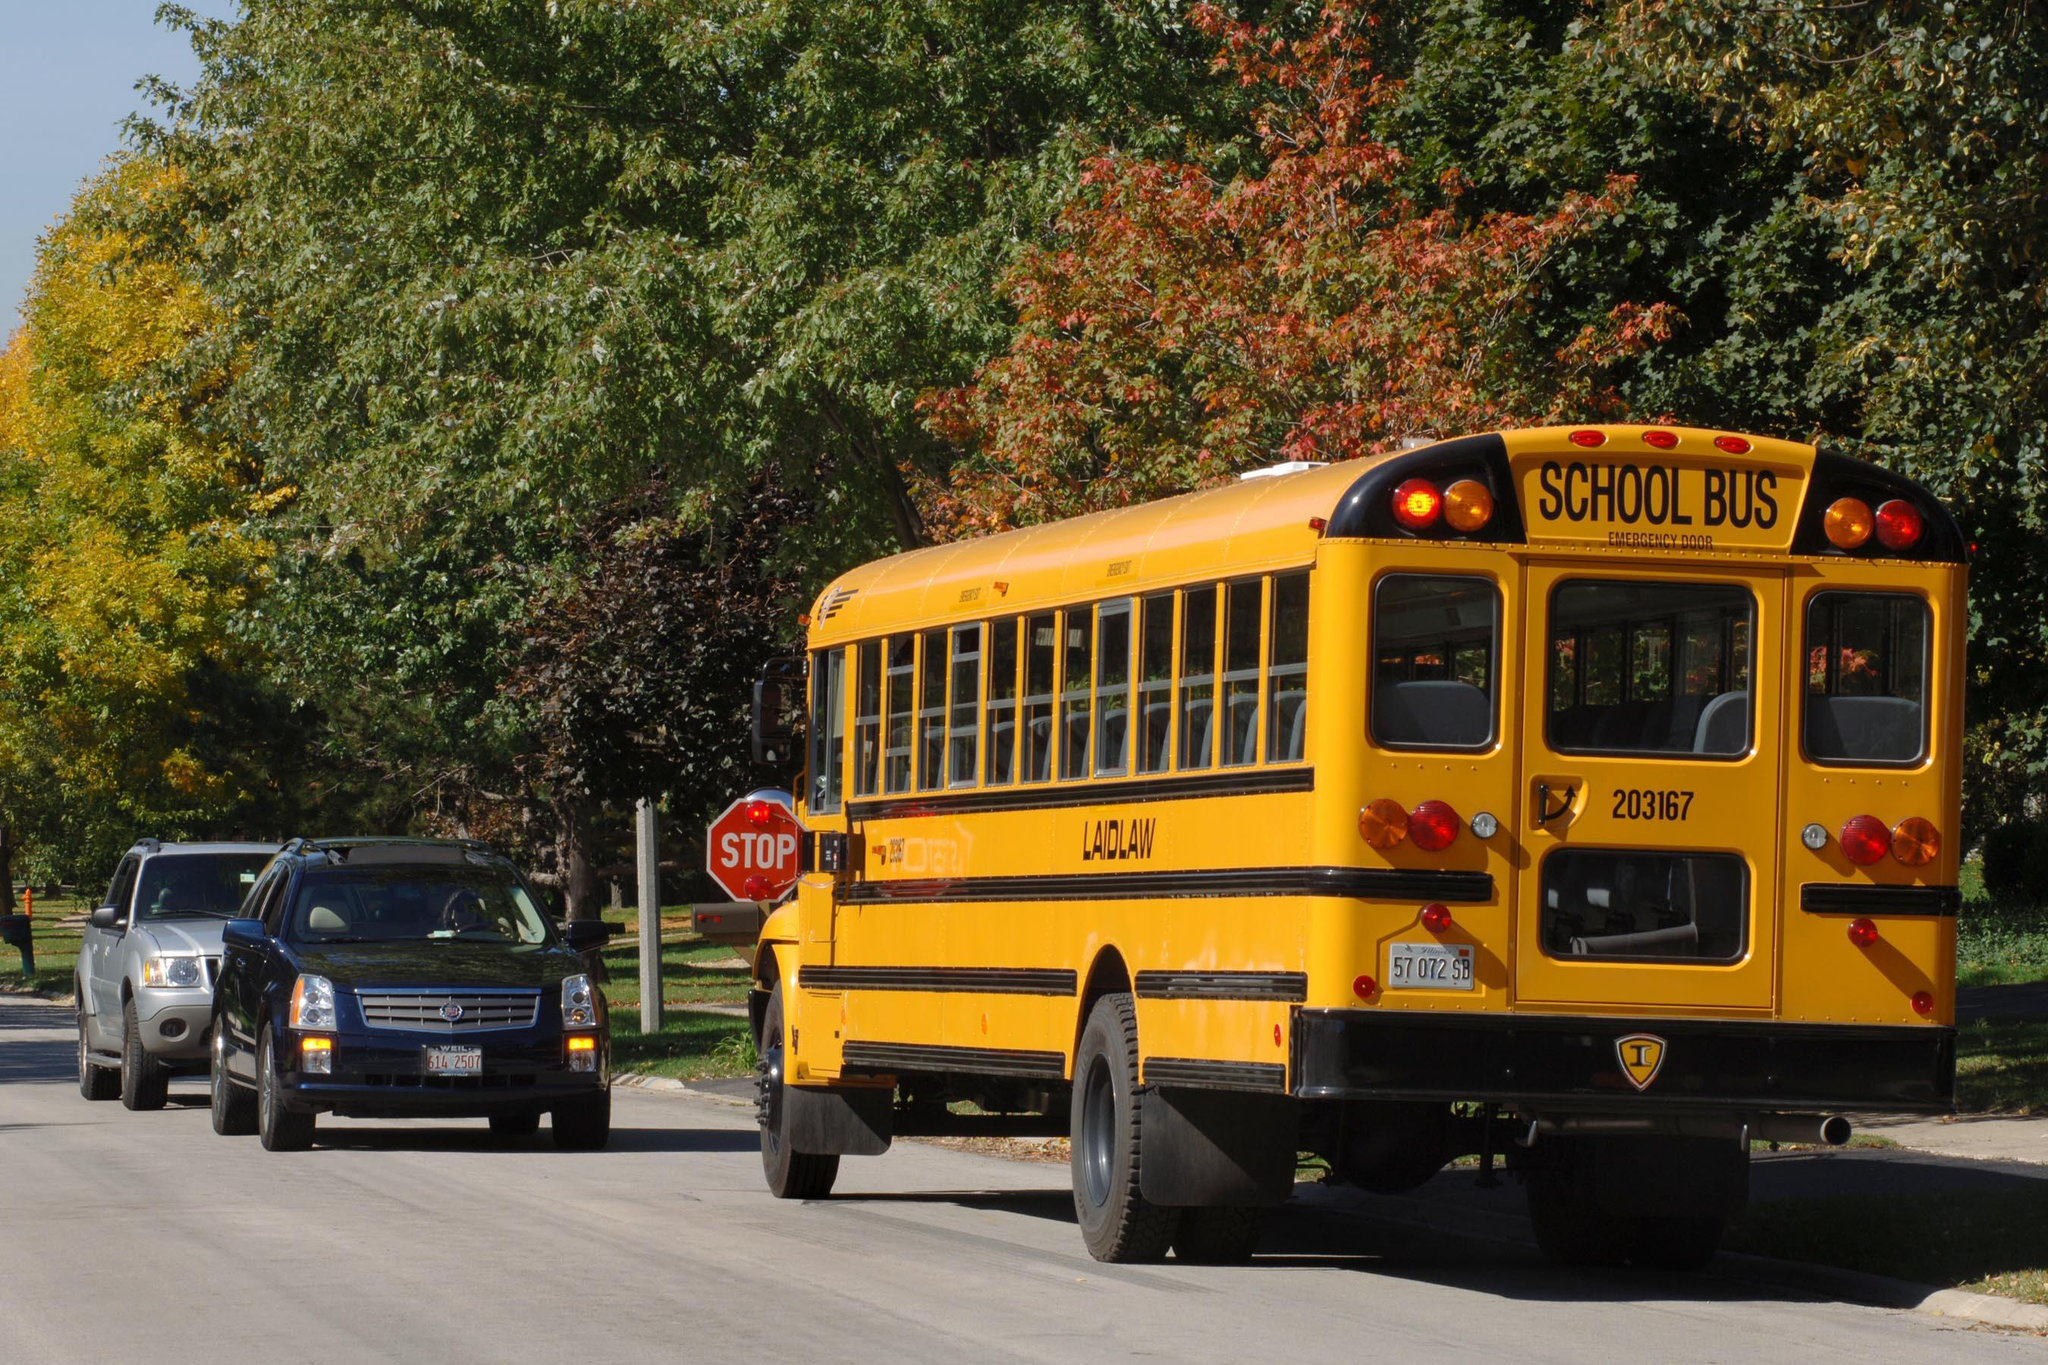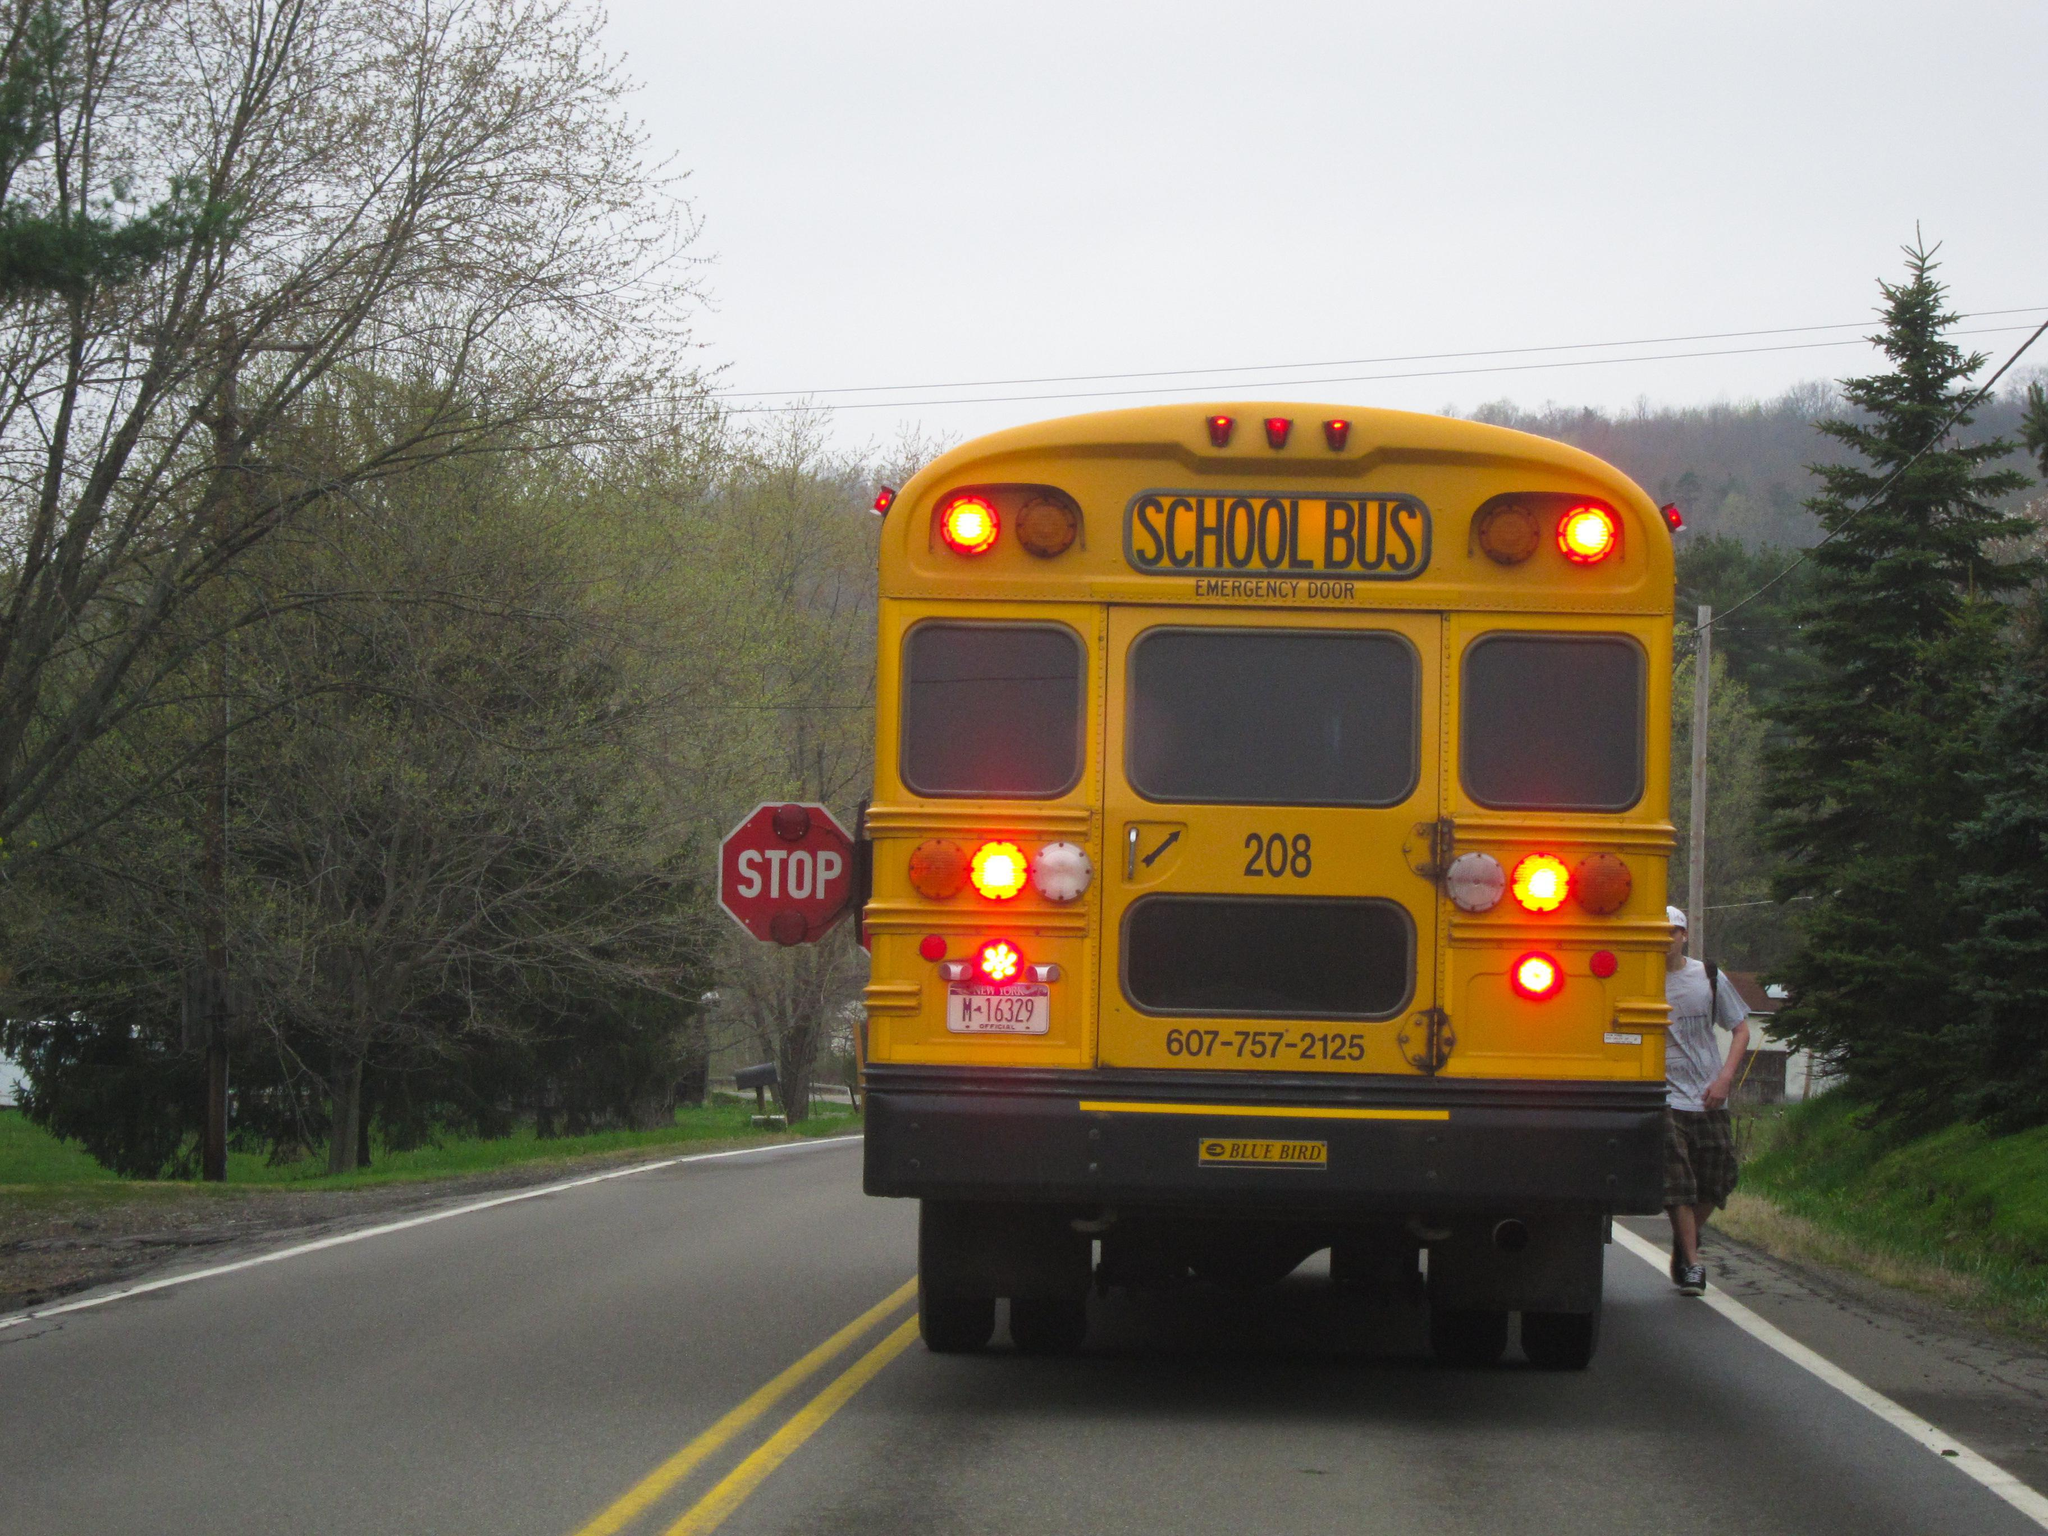The first image is the image on the left, the second image is the image on the right. Given the left and right images, does the statement "The front of the buses in both pictures are facing the left of the picture." hold true? Answer yes or no. No. The first image is the image on the left, the second image is the image on the right. Considering the images on both sides, is "One of the images shows a school bus with its stop sign extended and the other image shows a school bus without an extended stop sign." valid? Answer yes or no. No. 